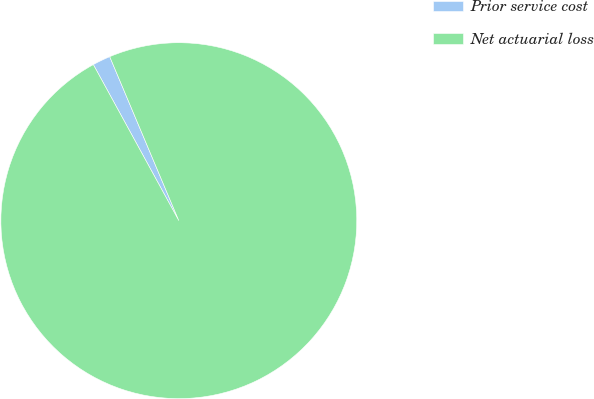Convert chart. <chart><loc_0><loc_0><loc_500><loc_500><pie_chart><fcel>Prior service cost<fcel>Net actuarial loss<nl><fcel>1.63%<fcel>98.37%<nl></chart> 